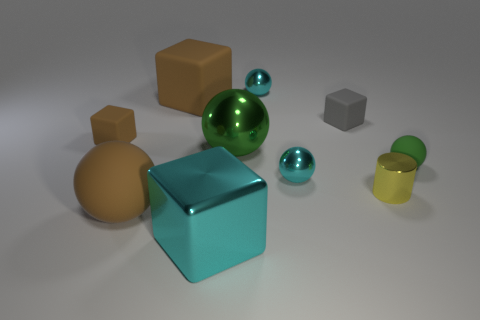Do the tiny brown thing and the big cyan object have the same shape?
Make the answer very short. Yes. Is the size of the brown thing left of the large rubber ball the same as the block that is right of the big cyan object?
Give a very brief answer. Yes. What material is the object that is left of the large cyan metal cube and behind the small gray object?
Your response must be concise. Rubber. Is there anything else that has the same color as the metallic cylinder?
Keep it short and to the point. No. Is the number of metallic balls that are on the right side of the yellow object less than the number of large brown metallic balls?
Provide a succinct answer. No. Is the number of tiny brown matte things greater than the number of tiny yellow rubber balls?
Your answer should be compact. Yes. There is a big metallic object that is right of the block in front of the large green shiny thing; is there a brown matte sphere in front of it?
Offer a very short reply. Yes. What number of other objects are the same size as the gray rubber block?
Your answer should be compact. 5. There is a small metallic cylinder; are there any green rubber balls to the left of it?
Your answer should be very brief. No. There is a large rubber cube; is it the same color as the rubber ball to the right of the large cyan thing?
Offer a terse response. No. 